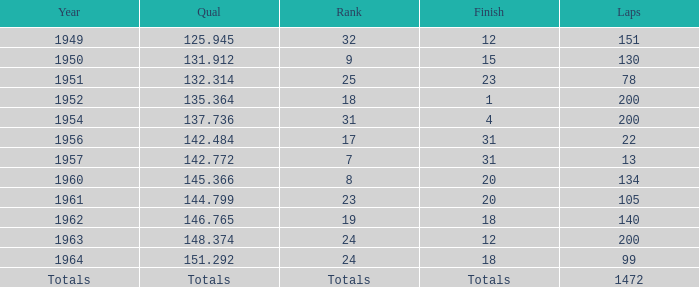Write the full table. {'header': ['Year', 'Qual', 'Rank', 'Finish', 'Laps'], 'rows': [['1949', '125.945', '32', '12', '151'], ['1950', '131.912', '9', '15', '130'], ['1951', '132.314', '25', '23', '78'], ['1952', '135.364', '18', '1', '200'], ['1954', '137.736', '31', '4', '200'], ['1956', '142.484', '17', '31', '22'], ['1957', '142.772', '7', '31', '13'], ['1960', '145.366', '8', '20', '134'], ['1961', '144.799', '23', '20', '105'], ['1962', '146.765', '19', '18', '140'], ['1963', '148.374', '24', '12', '200'], ['1964', '151.292', '24', '18', '99'], ['Totals', 'Totals', 'Totals', 'Totals', '1472']]} Name the rank for laps less than 130 and year of 1951 25.0. 